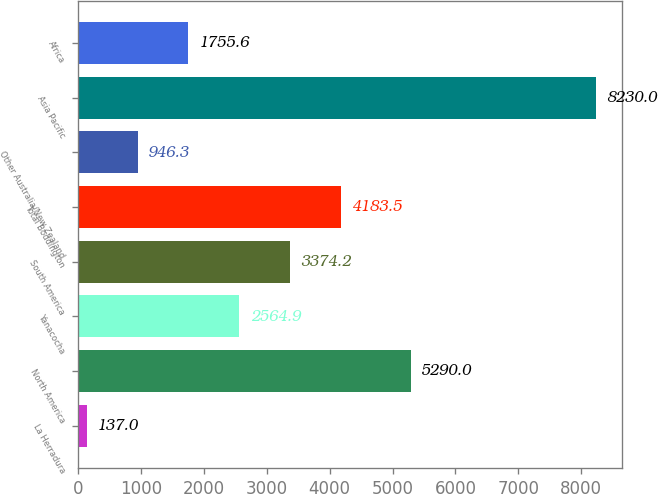Convert chart. <chart><loc_0><loc_0><loc_500><loc_500><bar_chart><fcel>La Herradura<fcel>North America<fcel>Yanacocha<fcel>South America<fcel>Total Boddington<fcel>Other Australia/New Zealand<fcel>Asia Pacific<fcel>Africa<nl><fcel>137<fcel>5290<fcel>2564.9<fcel>3374.2<fcel>4183.5<fcel>946.3<fcel>8230<fcel>1755.6<nl></chart> 